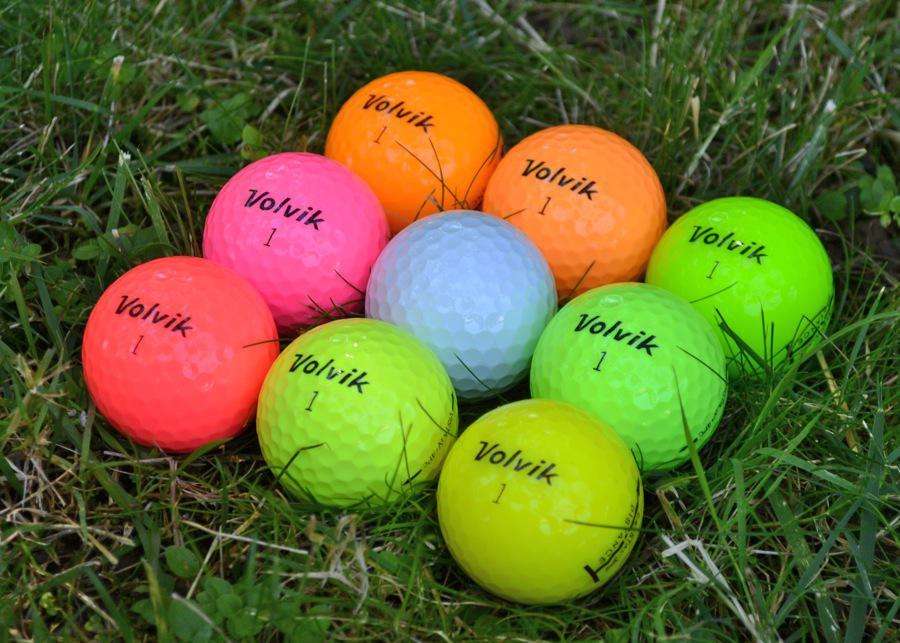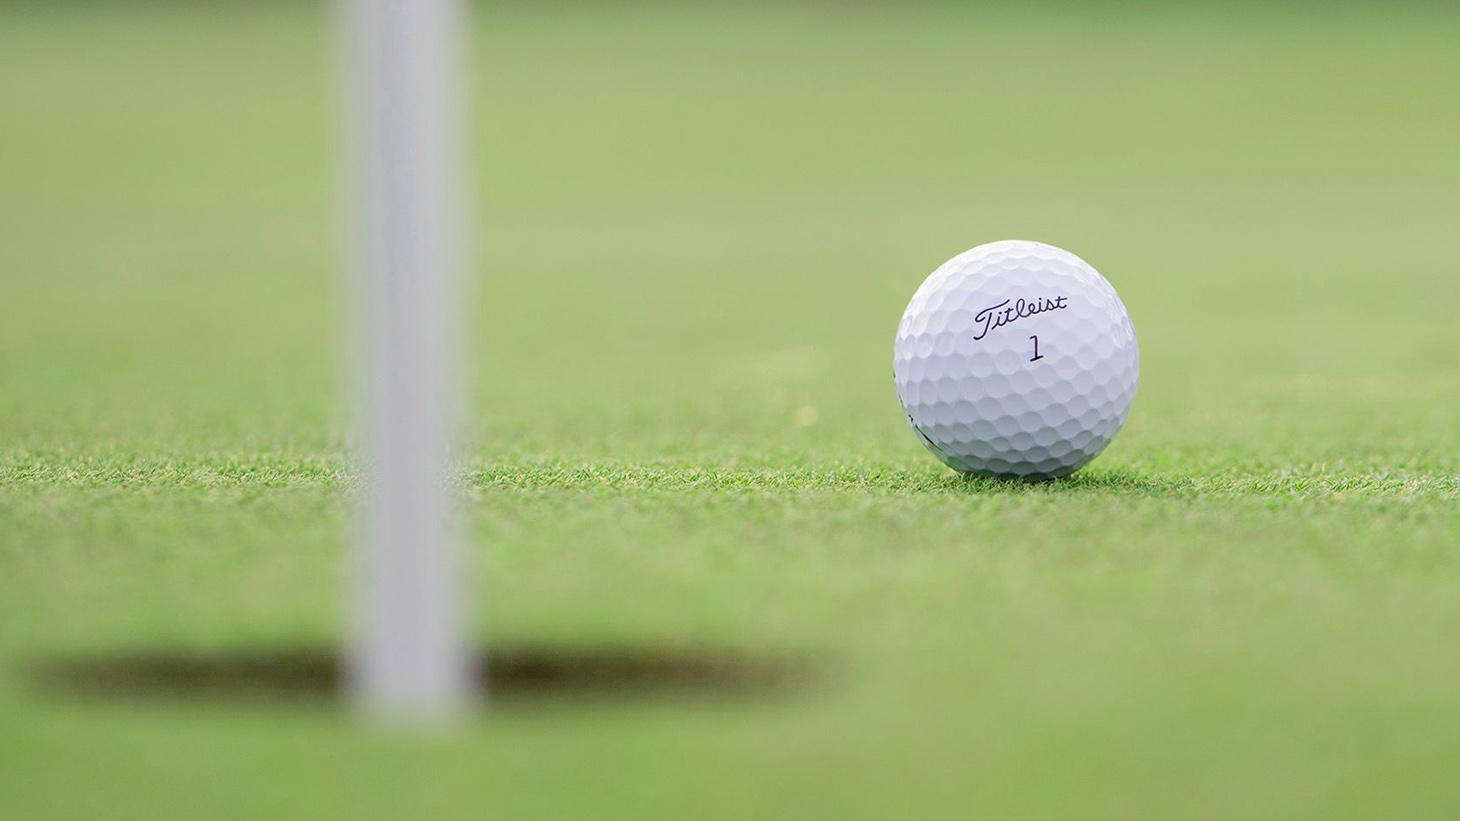The first image is the image on the left, the second image is the image on the right. Assess this claim about the two images: "There are at least seven golf balls.". Correct or not? Answer yes or no. Yes. 